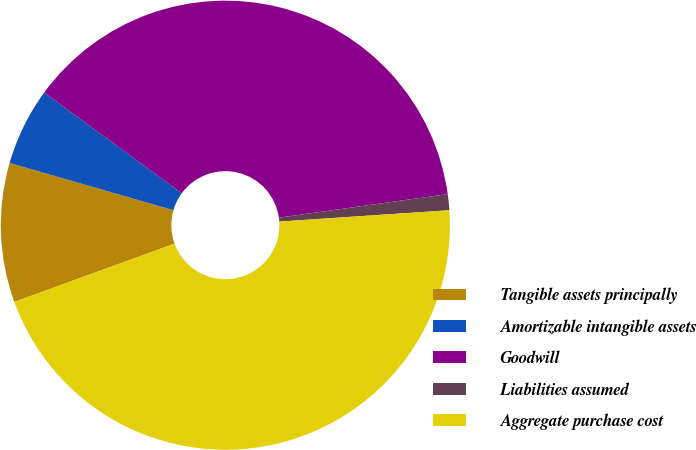Convert chart to OTSL. <chart><loc_0><loc_0><loc_500><loc_500><pie_chart><fcel>Tangible assets principally<fcel>Amortizable intangible assets<fcel>Goodwill<fcel>Liabilities assumed<fcel>Aggregate purchase cost<nl><fcel>10.02%<fcel>5.59%<fcel>37.73%<fcel>1.15%<fcel>45.51%<nl></chart> 